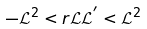Convert formula to latex. <formula><loc_0><loc_0><loc_500><loc_500>- \mathcal { L } ^ { 2 } < r \mathcal { L } \mathcal { L } ^ { ^ { \prime } } < \mathcal { L } ^ { 2 }</formula> 